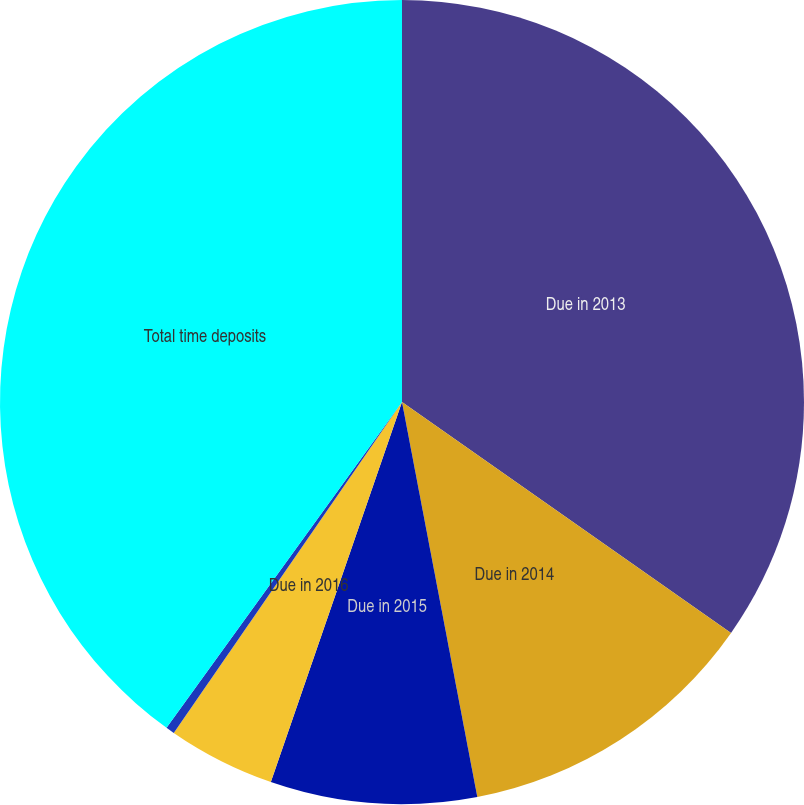<chart> <loc_0><loc_0><loc_500><loc_500><pie_chart><fcel>Due in 2013<fcel>Due in 2014<fcel>Due in 2015<fcel>Due in 2016<fcel>Due in 2017<fcel>Total time deposits<nl><fcel>34.74%<fcel>12.26%<fcel>8.29%<fcel>4.32%<fcel>0.35%<fcel>40.04%<nl></chart> 